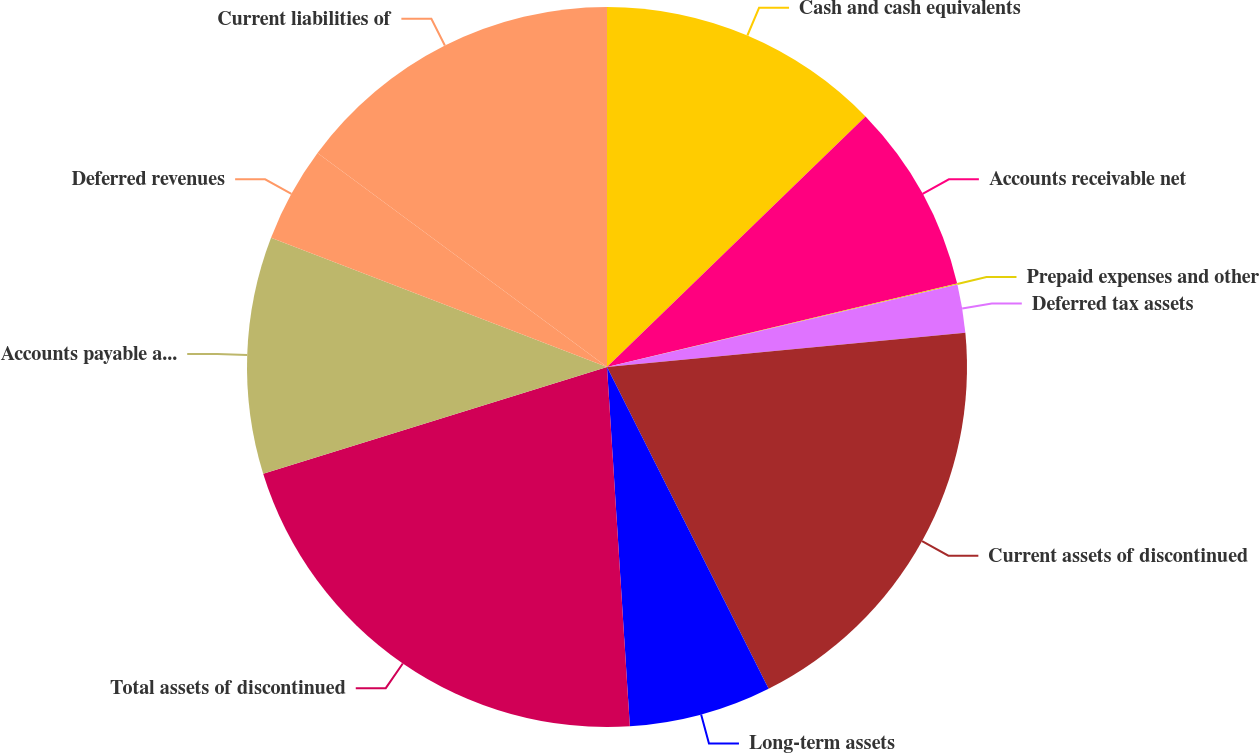<chart> <loc_0><loc_0><loc_500><loc_500><pie_chart><fcel>Cash and cash equivalents<fcel>Accounts receivable net<fcel>Prepaid expenses and other<fcel>Deferred tax assets<fcel>Current assets of discontinued<fcel>Long-term assets<fcel>Total assets of discontinued<fcel>Accounts payable and accrued<fcel>Deferred revenues<fcel>Current liabilities of<nl><fcel>12.75%<fcel>8.52%<fcel>0.05%<fcel>2.16%<fcel>19.11%<fcel>6.4%<fcel>21.22%<fcel>10.64%<fcel>4.28%<fcel>14.87%<nl></chart> 